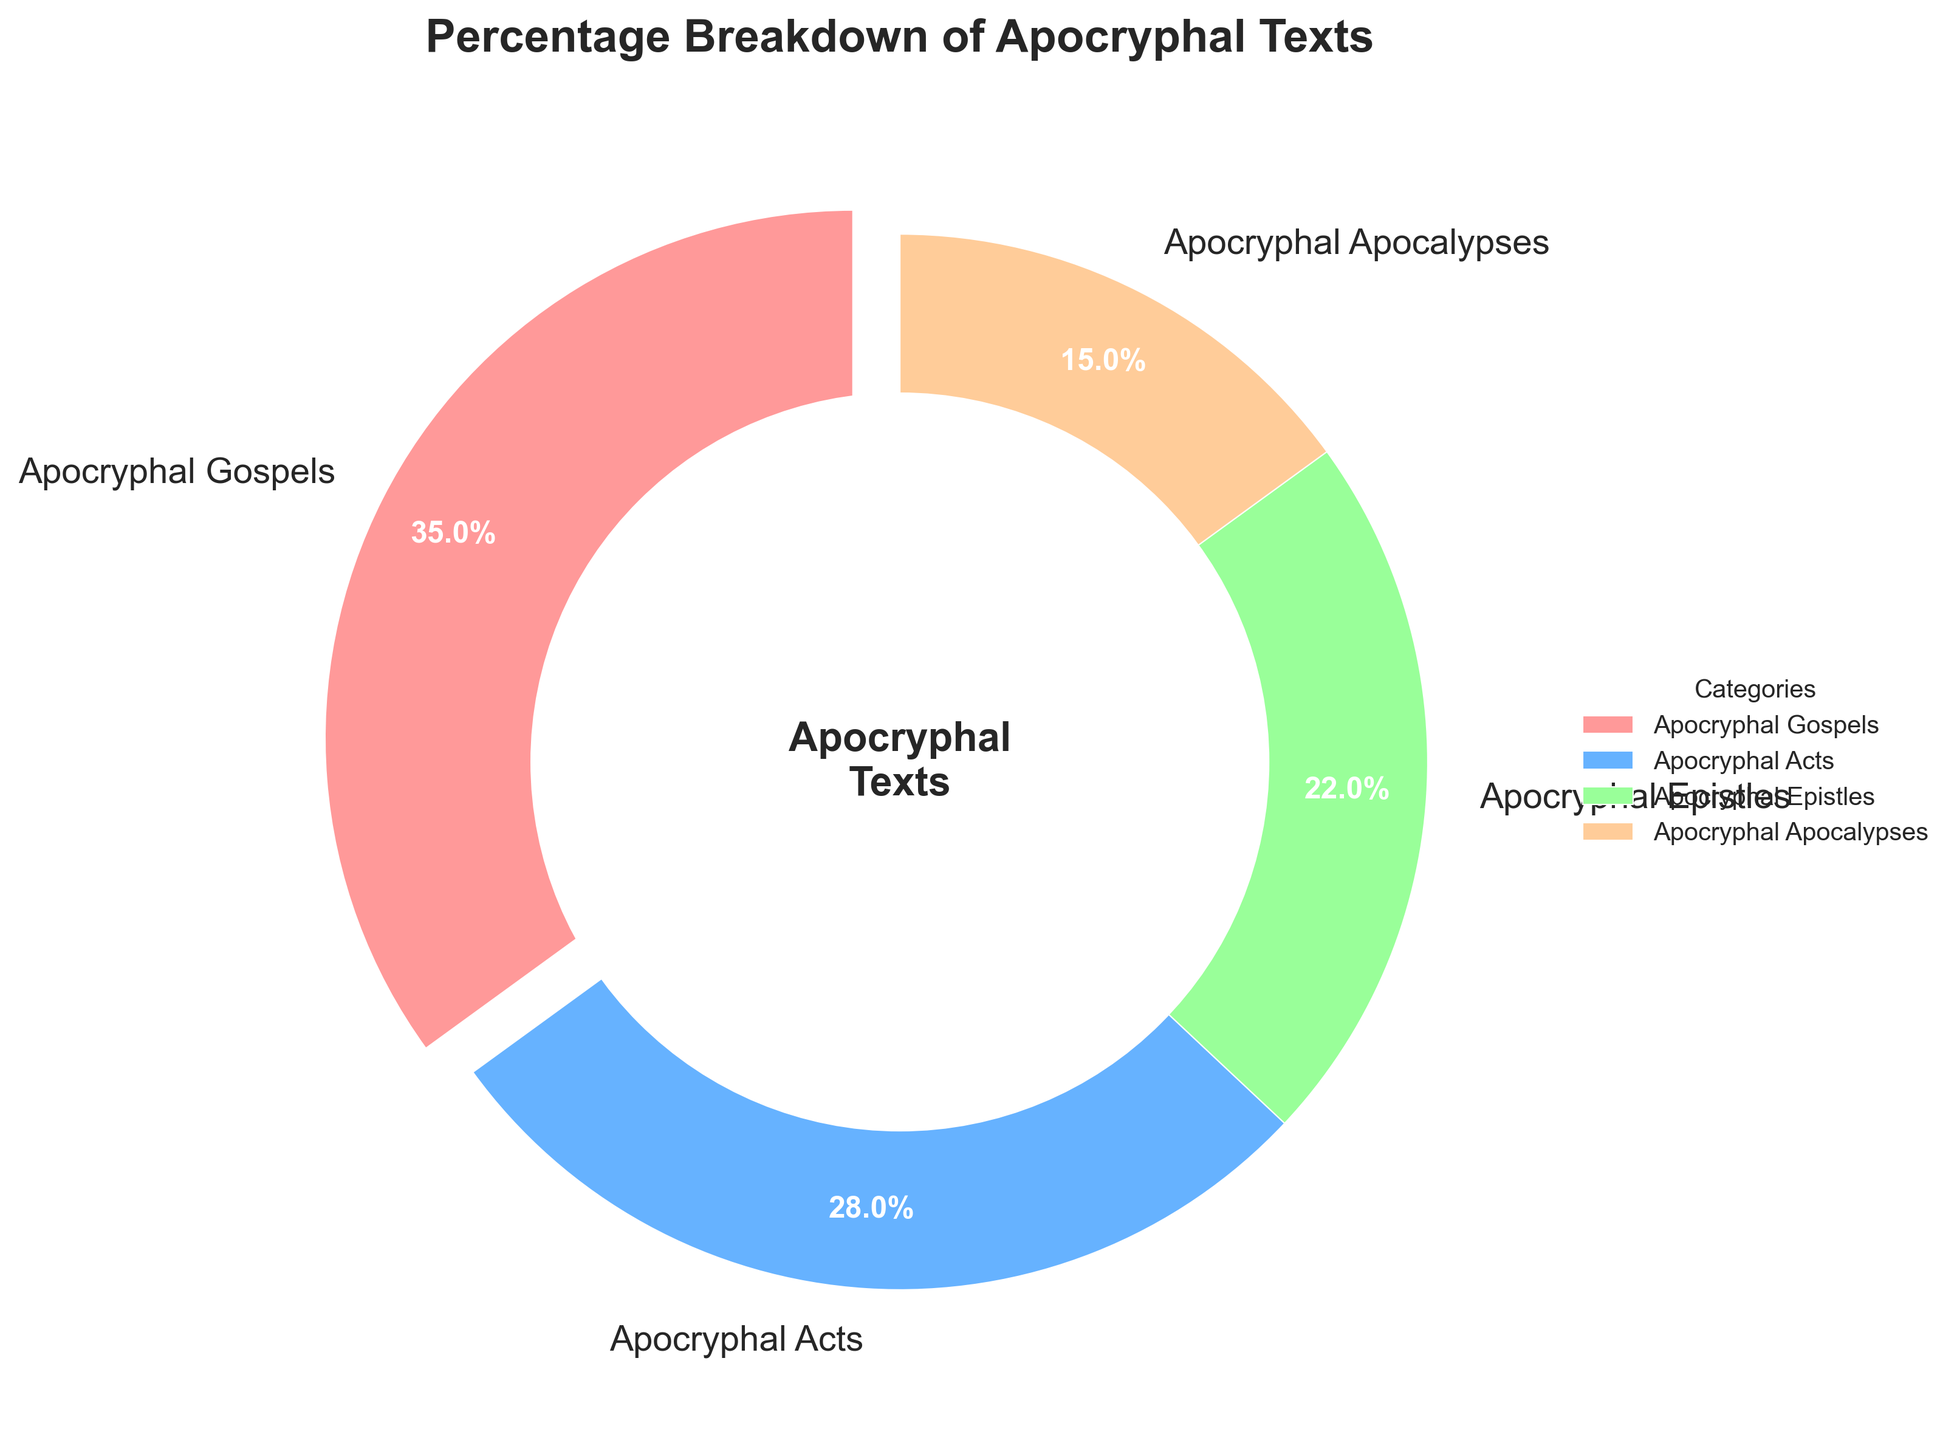What category has the highest percentage in the pie chart? The category with the highest percentage can be identified by observing the slices in the pie chart. The largest slice represents the "Apocryphal Gospels" with 35%.
Answer: Apocryphal Gospels What percentage of the pie chart is comprised by the Apocryphal Epistles and Apocryphal Apocalypses combined? Add the percentages of "Apocryphal Epistles" (22%) and "Apocryphal Apocalypses" (15%) to find the total percentage. 22% + 15% = 37%
Answer: 37% Which category comprises more of the pie chart: Apocryphal Acts or Apocryphal Epistles? Compare the percentages for "Apocryphal Acts" and "Apocryphal Epistles". Apocryphal Acts is 28% and Apocryphal Epistles is 22%. Hence, Apocryphal Acts comprises more.
Answer: Apocryphal Acts How much smaller is the percentage of Apocryphal Apocalypses compared to Apocryphal Gospels? Subtract the percentage of "Apocryphal Apocalypses" (15%) from "Apocryphal Gospels" (35%). 35% - 15% = 20%
Answer: 20% What is the second largest category in the pie chart? The largest category is "Apocryphal Gospels" (35%). The next largest percentage slice is "Apocryphal Acts" with 28%.
Answer: Apocryphal Acts If one removes the Apocryphal Apocalypses, what would the new total percentage of the pie chart be for the remaining categories? The total percentage of all categories is 100%. Removing "Apocryphal Apocalypses" (15%) leaves a total of 100% - 15% = 85% for the remaining categories.
Answer: 85% What is the difference in percentage between the smallest and the largest categories? The smallest category is "Apocryphal Apocalypses" (15%), and the largest is "Apocryphal Gospels" (35%). The difference is 35% - 15% = 20%.
Answer: 20% Which color represents the Apocryphal Acts category? By looking at the pie chart, the slice representing "Apocryphal Acts" is typically a certain color. For this chart, "Apocryphal Acts" is represented by blue.
Answer: Blue 